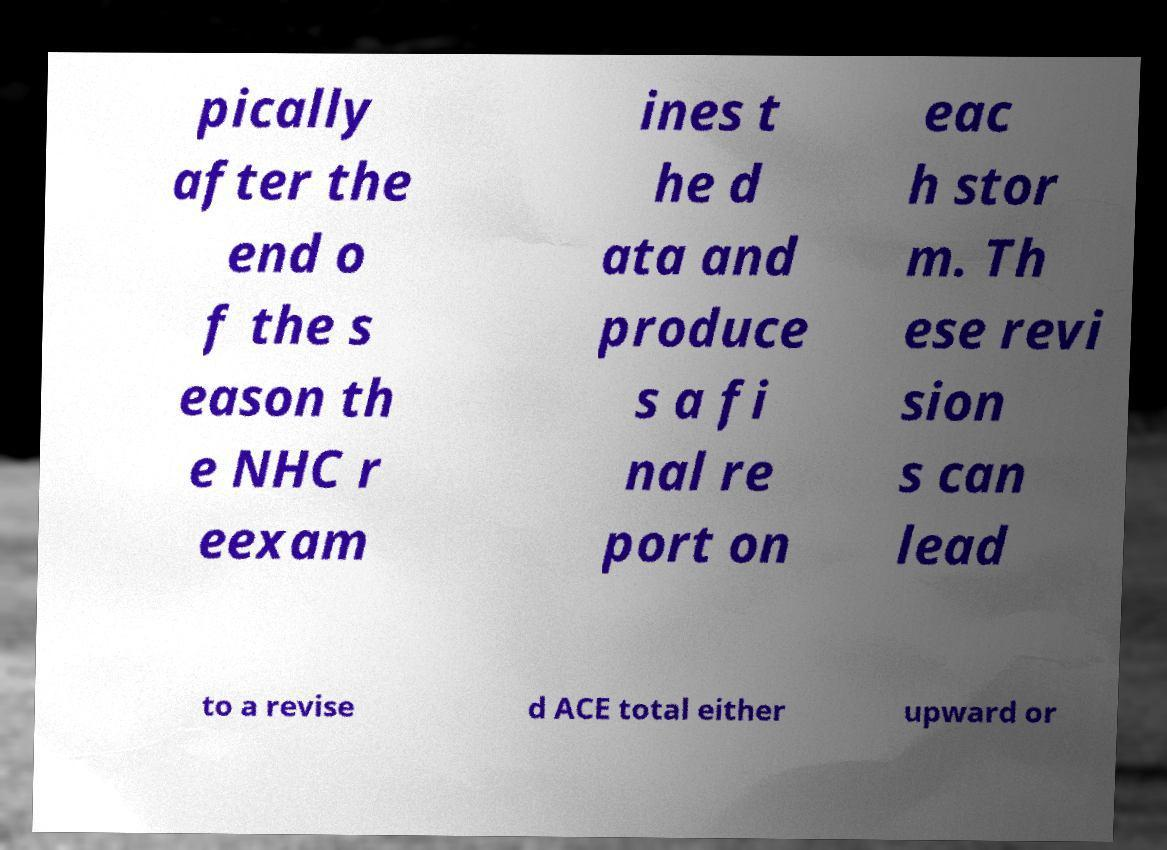Can you read and provide the text displayed in the image?This photo seems to have some interesting text. Can you extract and type it out for me? pically after the end o f the s eason th e NHC r eexam ines t he d ata and produce s a fi nal re port on eac h stor m. Th ese revi sion s can lead to a revise d ACE total either upward or 